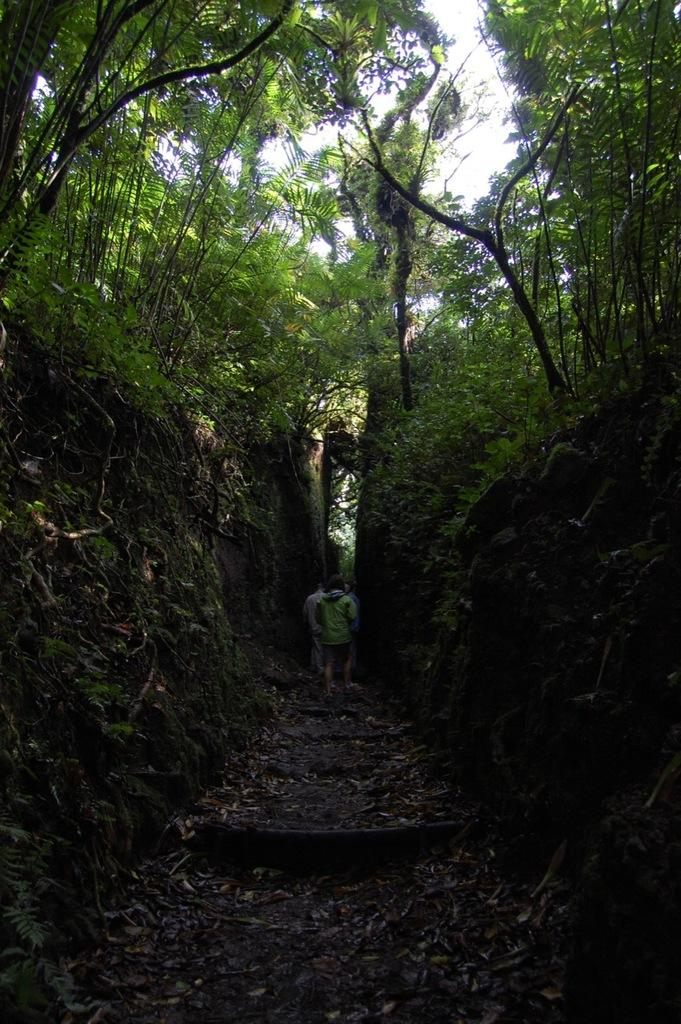How many people are in the image? There are people in the image, but the exact number is not specified. What is the surface under the people's feet? The ground is visible in the image, and grass is present on the ground. What type of vegetation can be seen in the image? Plants and trees are visible in the image. What is the condition of the path in the image? The path has dry leaves in the image. What is visible in the sky in the image? The sky is visible in the image, but no specific details about the sky are provided. What type of seed can be seen growing on the skate in the image? There is no skate or seed present in the image. 